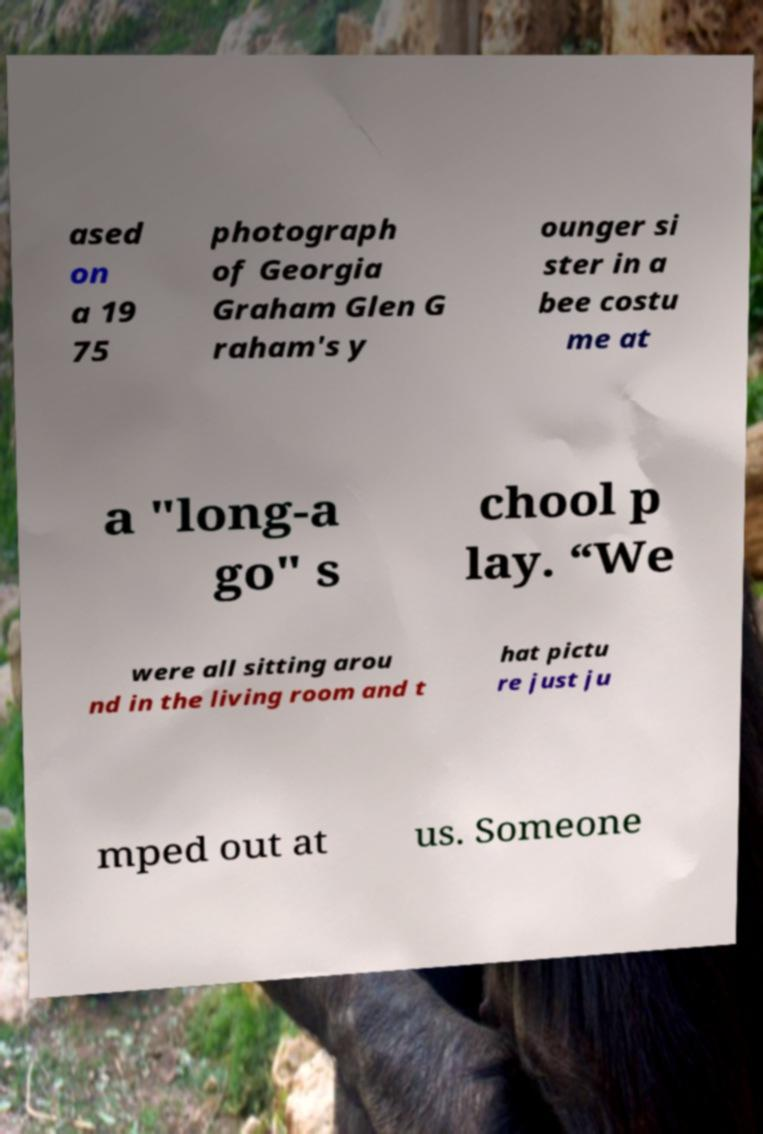Can you read and provide the text displayed in the image?This photo seems to have some interesting text. Can you extract and type it out for me? ased on a 19 75 photograph of Georgia Graham Glen G raham's y ounger si ster in a bee costu me at a "long-a go" s chool p lay. “We were all sitting arou nd in the living room and t hat pictu re just ju mped out at us. Someone 